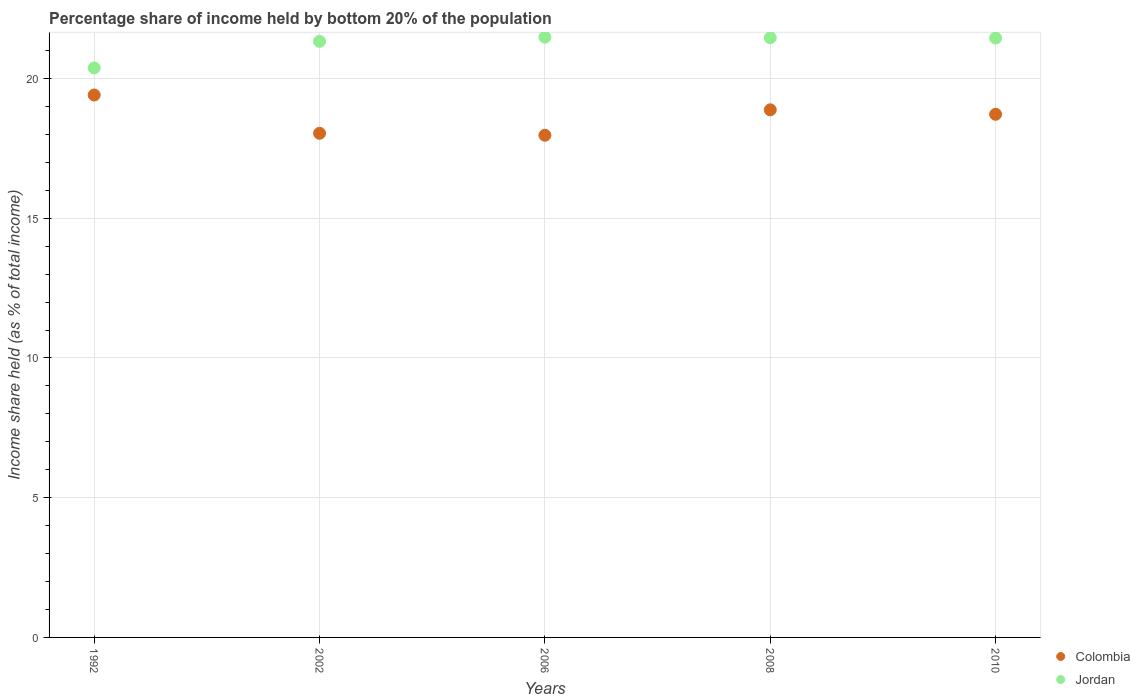How many different coloured dotlines are there?
Give a very brief answer. 2. Is the number of dotlines equal to the number of legend labels?
Keep it short and to the point. Yes. What is the share of income held by bottom 20% of the population in Colombia in 2010?
Ensure brevity in your answer.  18.72. Across all years, what is the maximum share of income held by bottom 20% of the population in Jordan?
Give a very brief answer. 21.48. Across all years, what is the minimum share of income held by bottom 20% of the population in Colombia?
Keep it short and to the point. 17.97. What is the total share of income held by bottom 20% of the population in Colombia in the graph?
Give a very brief answer. 93.02. What is the difference between the share of income held by bottom 20% of the population in Colombia in 2002 and that in 2008?
Your answer should be compact. -0.84. What is the difference between the share of income held by bottom 20% of the population in Colombia in 2002 and the share of income held by bottom 20% of the population in Jordan in 1992?
Give a very brief answer. -2.34. What is the average share of income held by bottom 20% of the population in Jordan per year?
Provide a succinct answer. 21.22. In the year 2008, what is the difference between the share of income held by bottom 20% of the population in Colombia and share of income held by bottom 20% of the population in Jordan?
Your answer should be compact. -2.58. In how many years, is the share of income held by bottom 20% of the population in Jordan greater than 12 %?
Ensure brevity in your answer.  5. What is the ratio of the share of income held by bottom 20% of the population in Colombia in 1992 to that in 2010?
Offer a terse response. 1.04. Is the share of income held by bottom 20% of the population in Jordan in 2006 less than that in 2008?
Ensure brevity in your answer.  No. What is the difference between the highest and the second highest share of income held by bottom 20% of the population in Colombia?
Your answer should be very brief. 0.53. What is the difference between the highest and the lowest share of income held by bottom 20% of the population in Colombia?
Ensure brevity in your answer.  1.44. In how many years, is the share of income held by bottom 20% of the population in Jordan greater than the average share of income held by bottom 20% of the population in Jordan taken over all years?
Ensure brevity in your answer.  4. Is the share of income held by bottom 20% of the population in Colombia strictly less than the share of income held by bottom 20% of the population in Jordan over the years?
Offer a terse response. Yes. How many years are there in the graph?
Provide a succinct answer. 5. Are the values on the major ticks of Y-axis written in scientific E-notation?
Keep it short and to the point. No. Does the graph contain any zero values?
Offer a terse response. No. Does the graph contain grids?
Your answer should be very brief. Yes. Where does the legend appear in the graph?
Offer a terse response. Bottom right. How many legend labels are there?
Ensure brevity in your answer.  2. What is the title of the graph?
Provide a succinct answer. Percentage share of income held by bottom 20% of the population. Does "France" appear as one of the legend labels in the graph?
Your answer should be very brief. No. What is the label or title of the X-axis?
Provide a succinct answer. Years. What is the label or title of the Y-axis?
Provide a succinct answer. Income share held (as % of total income). What is the Income share held (as % of total income) in Colombia in 1992?
Offer a very short reply. 19.41. What is the Income share held (as % of total income) in Jordan in 1992?
Provide a succinct answer. 20.38. What is the Income share held (as % of total income) in Colombia in 2002?
Offer a very short reply. 18.04. What is the Income share held (as % of total income) of Jordan in 2002?
Offer a very short reply. 21.33. What is the Income share held (as % of total income) of Colombia in 2006?
Your answer should be very brief. 17.97. What is the Income share held (as % of total income) in Jordan in 2006?
Keep it short and to the point. 21.48. What is the Income share held (as % of total income) in Colombia in 2008?
Offer a terse response. 18.88. What is the Income share held (as % of total income) in Jordan in 2008?
Your answer should be very brief. 21.46. What is the Income share held (as % of total income) of Colombia in 2010?
Give a very brief answer. 18.72. What is the Income share held (as % of total income) in Jordan in 2010?
Your response must be concise. 21.45. Across all years, what is the maximum Income share held (as % of total income) in Colombia?
Make the answer very short. 19.41. Across all years, what is the maximum Income share held (as % of total income) of Jordan?
Your answer should be very brief. 21.48. Across all years, what is the minimum Income share held (as % of total income) in Colombia?
Your answer should be very brief. 17.97. Across all years, what is the minimum Income share held (as % of total income) of Jordan?
Provide a short and direct response. 20.38. What is the total Income share held (as % of total income) in Colombia in the graph?
Offer a very short reply. 93.02. What is the total Income share held (as % of total income) of Jordan in the graph?
Make the answer very short. 106.1. What is the difference between the Income share held (as % of total income) in Colombia in 1992 and that in 2002?
Your answer should be compact. 1.37. What is the difference between the Income share held (as % of total income) in Jordan in 1992 and that in 2002?
Offer a terse response. -0.95. What is the difference between the Income share held (as % of total income) of Colombia in 1992 and that in 2006?
Keep it short and to the point. 1.44. What is the difference between the Income share held (as % of total income) in Colombia in 1992 and that in 2008?
Provide a succinct answer. 0.53. What is the difference between the Income share held (as % of total income) in Jordan in 1992 and that in 2008?
Make the answer very short. -1.08. What is the difference between the Income share held (as % of total income) in Colombia in 1992 and that in 2010?
Give a very brief answer. 0.69. What is the difference between the Income share held (as % of total income) of Jordan in 1992 and that in 2010?
Your answer should be very brief. -1.07. What is the difference between the Income share held (as % of total income) of Colombia in 2002 and that in 2006?
Your response must be concise. 0.07. What is the difference between the Income share held (as % of total income) of Colombia in 2002 and that in 2008?
Provide a succinct answer. -0.84. What is the difference between the Income share held (as % of total income) of Jordan in 2002 and that in 2008?
Keep it short and to the point. -0.13. What is the difference between the Income share held (as % of total income) of Colombia in 2002 and that in 2010?
Offer a very short reply. -0.68. What is the difference between the Income share held (as % of total income) in Jordan in 2002 and that in 2010?
Make the answer very short. -0.12. What is the difference between the Income share held (as % of total income) of Colombia in 2006 and that in 2008?
Ensure brevity in your answer.  -0.91. What is the difference between the Income share held (as % of total income) in Jordan in 2006 and that in 2008?
Your response must be concise. 0.02. What is the difference between the Income share held (as % of total income) in Colombia in 2006 and that in 2010?
Keep it short and to the point. -0.75. What is the difference between the Income share held (as % of total income) in Jordan in 2006 and that in 2010?
Offer a terse response. 0.03. What is the difference between the Income share held (as % of total income) in Colombia in 2008 and that in 2010?
Your answer should be compact. 0.16. What is the difference between the Income share held (as % of total income) in Colombia in 1992 and the Income share held (as % of total income) in Jordan in 2002?
Give a very brief answer. -1.92. What is the difference between the Income share held (as % of total income) of Colombia in 1992 and the Income share held (as % of total income) of Jordan in 2006?
Your answer should be compact. -2.07. What is the difference between the Income share held (as % of total income) of Colombia in 1992 and the Income share held (as % of total income) of Jordan in 2008?
Keep it short and to the point. -2.05. What is the difference between the Income share held (as % of total income) in Colombia in 1992 and the Income share held (as % of total income) in Jordan in 2010?
Your answer should be compact. -2.04. What is the difference between the Income share held (as % of total income) of Colombia in 2002 and the Income share held (as % of total income) of Jordan in 2006?
Keep it short and to the point. -3.44. What is the difference between the Income share held (as % of total income) of Colombia in 2002 and the Income share held (as % of total income) of Jordan in 2008?
Your answer should be compact. -3.42. What is the difference between the Income share held (as % of total income) in Colombia in 2002 and the Income share held (as % of total income) in Jordan in 2010?
Offer a terse response. -3.41. What is the difference between the Income share held (as % of total income) of Colombia in 2006 and the Income share held (as % of total income) of Jordan in 2008?
Give a very brief answer. -3.49. What is the difference between the Income share held (as % of total income) in Colombia in 2006 and the Income share held (as % of total income) in Jordan in 2010?
Your answer should be very brief. -3.48. What is the difference between the Income share held (as % of total income) in Colombia in 2008 and the Income share held (as % of total income) in Jordan in 2010?
Your response must be concise. -2.57. What is the average Income share held (as % of total income) in Colombia per year?
Provide a short and direct response. 18.6. What is the average Income share held (as % of total income) of Jordan per year?
Your answer should be compact. 21.22. In the year 1992, what is the difference between the Income share held (as % of total income) of Colombia and Income share held (as % of total income) of Jordan?
Ensure brevity in your answer.  -0.97. In the year 2002, what is the difference between the Income share held (as % of total income) of Colombia and Income share held (as % of total income) of Jordan?
Your response must be concise. -3.29. In the year 2006, what is the difference between the Income share held (as % of total income) of Colombia and Income share held (as % of total income) of Jordan?
Provide a short and direct response. -3.51. In the year 2008, what is the difference between the Income share held (as % of total income) of Colombia and Income share held (as % of total income) of Jordan?
Provide a succinct answer. -2.58. In the year 2010, what is the difference between the Income share held (as % of total income) in Colombia and Income share held (as % of total income) in Jordan?
Make the answer very short. -2.73. What is the ratio of the Income share held (as % of total income) of Colombia in 1992 to that in 2002?
Your answer should be very brief. 1.08. What is the ratio of the Income share held (as % of total income) in Jordan in 1992 to that in 2002?
Keep it short and to the point. 0.96. What is the ratio of the Income share held (as % of total income) in Colombia in 1992 to that in 2006?
Make the answer very short. 1.08. What is the ratio of the Income share held (as % of total income) in Jordan in 1992 to that in 2006?
Provide a short and direct response. 0.95. What is the ratio of the Income share held (as % of total income) in Colombia in 1992 to that in 2008?
Give a very brief answer. 1.03. What is the ratio of the Income share held (as % of total income) in Jordan in 1992 to that in 2008?
Ensure brevity in your answer.  0.95. What is the ratio of the Income share held (as % of total income) in Colombia in 1992 to that in 2010?
Provide a succinct answer. 1.04. What is the ratio of the Income share held (as % of total income) of Jordan in 1992 to that in 2010?
Provide a short and direct response. 0.95. What is the ratio of the Income share held (as % of total income) of Colombia in 2002 to that in 2006?
Provide a short and direct response. 1. What is the ratio of the Income share held (as % of total income) of Jordan in 2002 to that in 2006?
Offer a terse response. 0.99. What is the ratio of the Income share held (as % of total income) in Colombia in 2002 to that in 2008?
Your answer should be very brief. 0.96. What is the ratio of the Income share held (as % of total income) in Jordan in 2002 to that in 2008?
Offer a terse response. 0.99. What is the ratio of the Income share held (as % of total income) in Colombia in 2002 to that in 2010?
Make the answer very short. 0.96. What is the ratio of the Income share held (as % of total income) in Jordan in 2002 to that in 2010?
Your answer should be compact. 0.99. What is the ratio of the Income share held (as % of total income) in Colombia in 2006 to that in 2008?
Offer a very short reply. 0.95. What is the ratio of the Income share held (as % of total income) in Colombia in 2006 to that in 2010?
Offer a very short reply. 0.96. What is the ratio of the Income share held (as % of total income) of Jordan in 2006 to that in 2010?
Your response must be concise. 1. What is the ratio of the Income share held (as % of total income) of Colombia in 2008 to that in 2010?
Give a very brief answer. 1.01. What is the difference between the highest and the second highest Income share held (as % of total income) of Colombia?
Your answer should be compact. 0.53. What is the difference between the highest and the lowest Income share held (as % of total income) in Colombia?
Offer a very short reply. 1.44. 